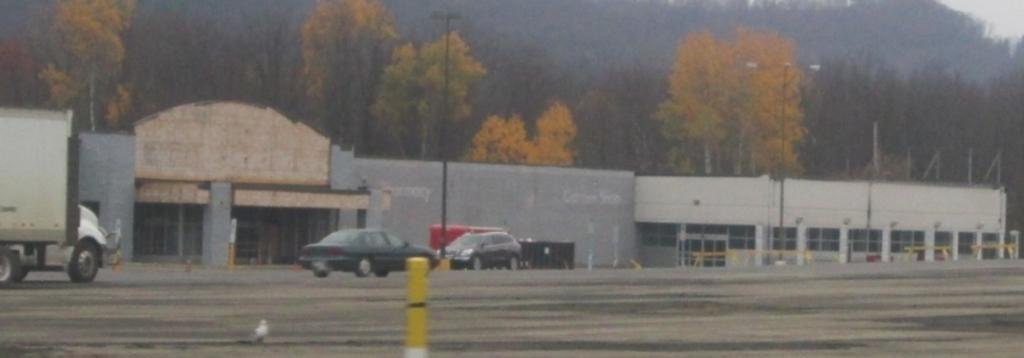What can be seen on the road in the image? There are vehicles on the road in the image. What type of poles are present in the image? There are light poles in the image. What structures can be seen in the background of the image? There are buildings, poles, trees, and doors visible in the background of the image. What part of the natural environment is visible in the background of the image? The sky is visible in the background of the image. Can you hear the whistle of the wind in the image? There is no mention of wind or a whistle in the image, so it cannot be heard. How does the temper of the trees affect the image? The image does not depict the temper of the trees, as trees do not have emotions. 